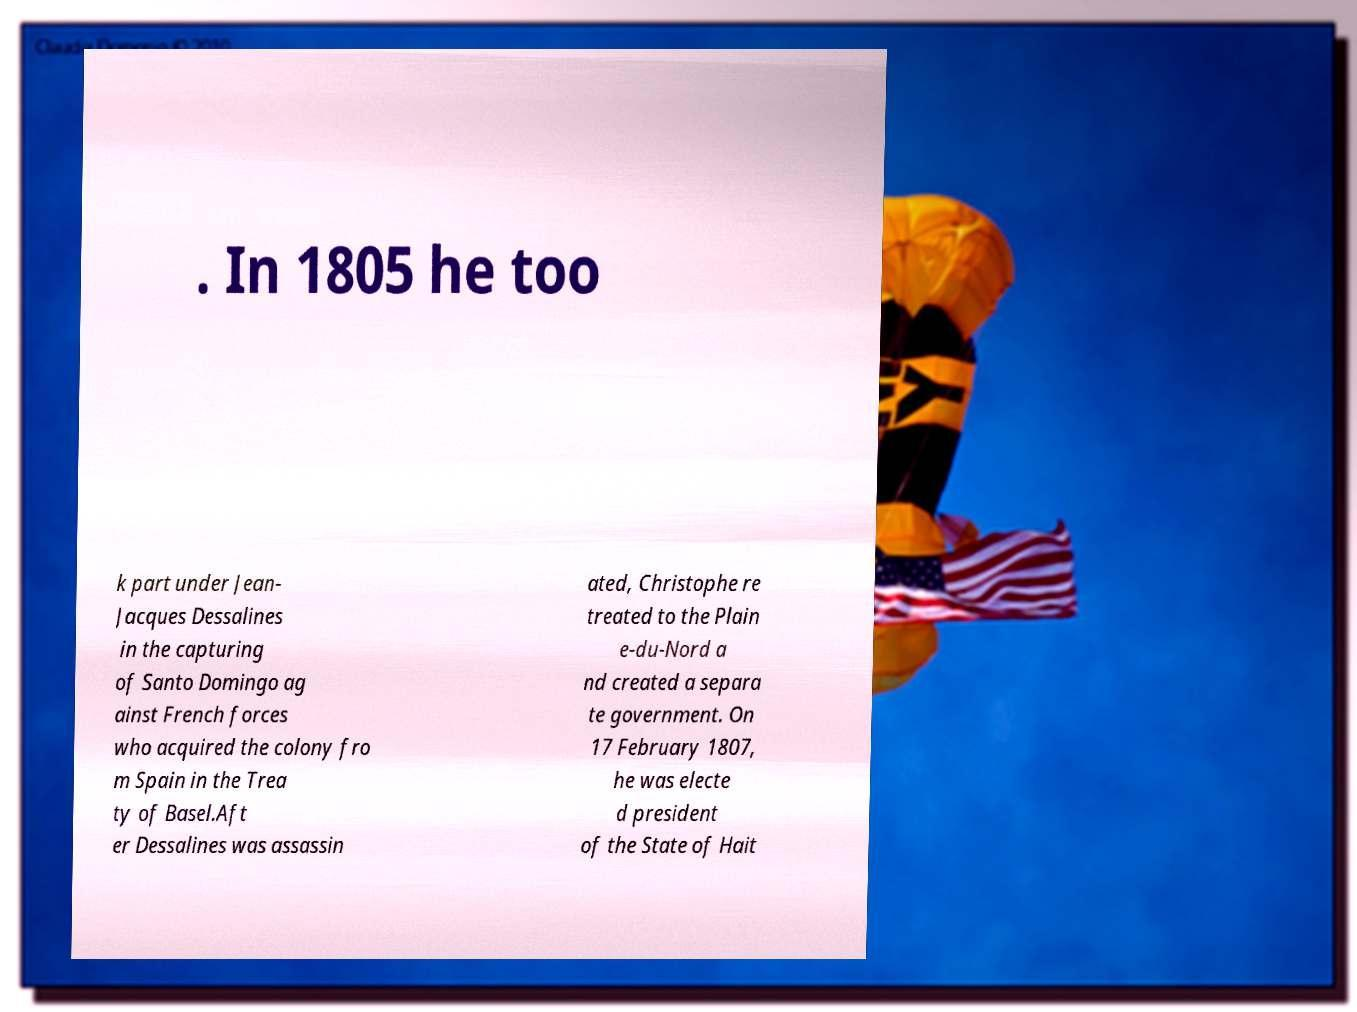Could you extract and type out the text from this image? . In 1805 he too k part under Jean- Jacques Dessalines in the capturing of Santo Domingo ag ainst French forces who acquired the colony fro m Spain in the Trea ty of Basel.Aft er Dessalines was assassin ated, Christophe re treated to the Plain e-du-Nord a nd created a separa te government. On 17 February 1807, he was electe d president of the State of Hait 